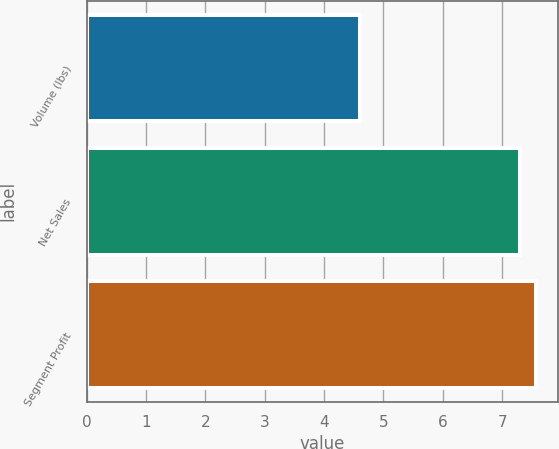Convert chart to OTSL. <chart><loc_0><loc_0><loc_500><loc_500><bar_chart><fcel>Volume (lbs)<fcel>Net Sales<fcel>Segment Profit<nl><fcel>4.6<fcel>7.3<fcel>7.57<nl></chart> 